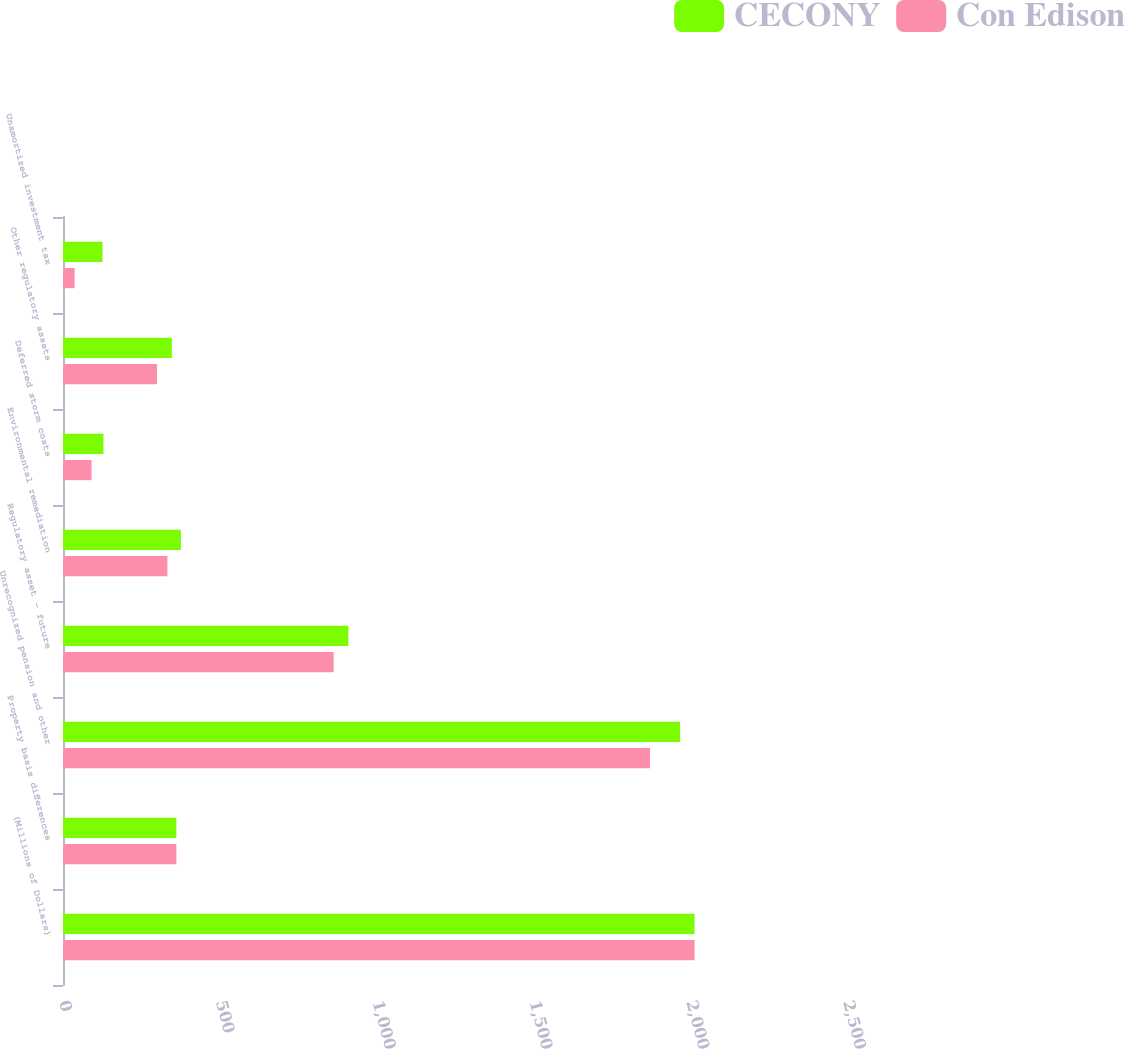Convert chart to OTSL. <chart><loc_0><loc_0><loc_500><loc_500><stacked_bar_chart><ecel><fcel>(Millions of Dollars)<fcel>Property basis differences<fcel>Unrecognized pension and other<fcel>Regulatory asset - future<fcel>Environmental remediation<fcel>Deferred storm costs<fcel>Other regulatory assets<fcel>Unamortized investment tax<nl><fcel>CECONY<fcel>2014<fcel>361.5<fcel>1968<fcel>910<fcel>376<fcel>129<fcel>347<fcel>126<nl><fcel>Con Edison<fcel>2014<fcel>361.5<fcel>1872<fcel>863<fcel>333<fcel>91<fcel>300<fcel>37<nl></chart> 